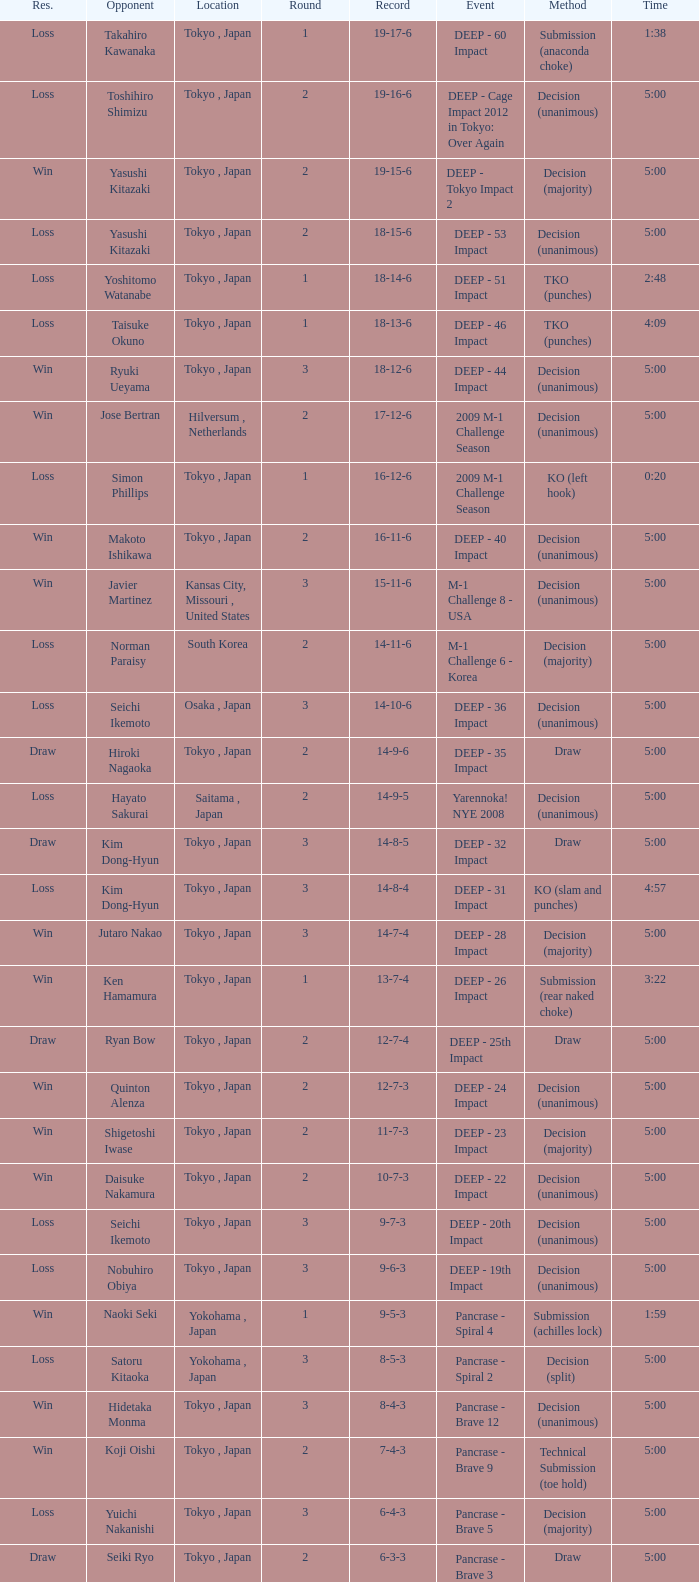What is the location when the method is tko (punches) and the time is 2:48? Tokyo , Japan. 